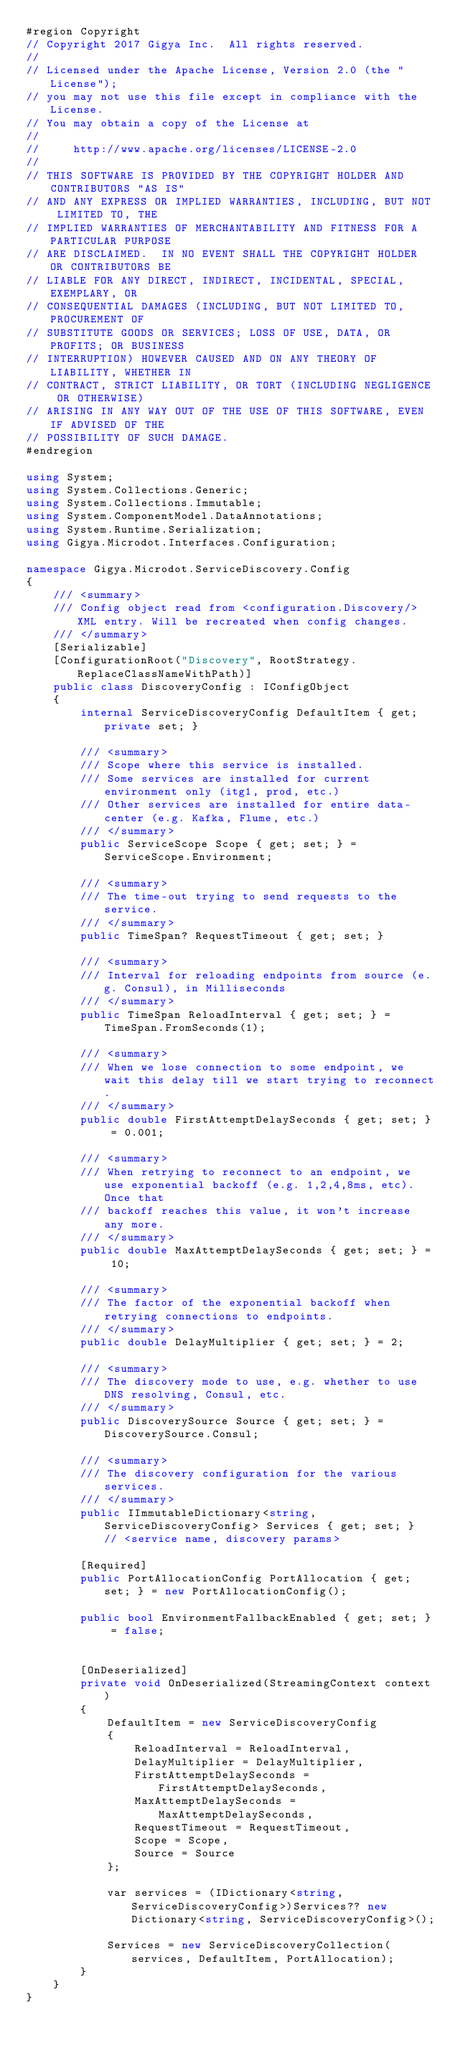Convert code to text. <code><loc_0><loc_0><loc_500><loc_500><_C#_>#region Copyright 
// Copyright 2017 Gigya Inc.  All rights reserved.
// 
// Licensed under the Apache License, Version 2.0 (the "License"); 
// you may not use this file except in compliance with the License.  
// You may obtain a copy of the License at
// 
//     http://www.apache.org/licenses/LICENSE-2.0
// 
// THIS SOFTWARE IS PROVIDED BY THE COPYRIGHT HOLDER AND CONTRIBUTORS "AS IS"
// AND ANY EXPRESS OR IMPLIED WARRANTIES, INCLUDING, BUT NOT LIMITED TO, THE
// IMPLIED WARRANTIES OF MERCHANTABILITY AND FITNESS FOR A PARTICULAR PURPOSE
// ARE DISCLAIMED.  IN NO EVENT SHALL THE COPYRIGHT HOLDER OR CONTRIBUTORS BE
// LIABLE FOR ANY DIRECT, INDIRECT, INCIDENTAL, SPECIAL, EXEMPLARY, OR
// CONSEQUENTIAL DAMAGES (INCLUDING, BUT NOT LIMITED TO, PROCUREMENT OF
// SUBSTITUTE GOODS OR SERVICES; LOSS OF USE, DATA, OR PROFITS; OR BUSINESS
// INTERRUPTION) HOWEVER CAUSED AND ON ANY THEORY OF LIABILITY, WHETHER IN
// CONTRACT, STRICT LIABILITY, OR TORT (INCLUDING NEGLIGENCE OR OTHERWISE)
// ARISING IN ANY WAY OUT OF THE USE OF THIS SOFTWARE, EVEN IF ADVISED OF THE
// POSSIBILITY OF SUCH DAMAGE.
#endregion

using System;
using System.Collections.Generic;
using System.Collections.Immutable;
using System.ComponentModel.DataAnnotations;
using System.Runtime.Serialization;
using Gigya.Microdot.Interfaces.Configuration;

namespace Gigya.Microdot.ServiceDiscovery.Config
{
    /// <summary>
    /// Config object read from <configuration.Discovery/> XML entry. Will be recreated when config changes.
    /// </summary>
    [Serializable]
    [ConfigurationRoot("Discovery", RootStrategy.ReplaceClassNameWithPath)]
    public class DiscoveryConfig : IConfigObject
    {
        internal ServiceDiscoveryConfig DefaultItem { get; private set; }

        /// <summary>
        /// Scope where this service is installed.
        /// Some services are installed for current environment only (itg1, prod, etc.)
        /// Other services are installed for entire data-center (e.g. Kafka, Flume, etc.)
        /// </summary>
        public ServiceScope Scope { get; set; } = ServiceScope.Environment;

        /// <summary>
        /// The time-out trying to send requests to the service.
        /// </summary>
        public TimeSpan? RequestTimeout { get; set; }

        /// <summary>
        /// Interval for reloading endpoints from source (e.g. Consul), in Milliseconds
        /// </summary>
        public TimeSpan ReloadInterval { get; set; } = TimeSpan.FromSeconds(1);

        /// <summary>
        /// When we lose connection to some endpoint, we wait this delay till we start trying to reconnect.
        /// </summary>
        public double FirstAttemptDelaySeconds { get; set; } = 0.001;

        /// <summary>
        /// When retrying to reconnect to an endpoint, we use exponential backoff (e.g. 1,2,4,8ms, etc). Once that
        /// backoff reaches this value, it won't increase any more.
        /// </summary>
        public double MaxAttemptDelaySeconds { get; set; } = 10;

        /// <summary>
        /// The factor of the exponential backoff when retrying connections to endpoints.
        /// </summary>
        public double DelayMultiplier { get; set; } = 2;

        /// <summary>
        /// The discovery mode to use, e.g. whether to use DNS resolving, Consul, etc.
        /// </summary>
        public DiscoverySource Source { get; set; } = DiscoverySource.Consul;

        /// <summary>
        /// The discovery configuration for the various services.
        /// </summary>
        public IImmutableDictionary<string, ServiceDiscoveryConfig> Services { get; set; }  // <service name, discovery params>

        [Required]
        public PortAllocationConfig PortAllocation { get; set; } = new PortAllocationConfig();

        public bool EnvironmentFallbackEnabled { get; set; } = false;


        [OnDeserialized]
        private void OnDeserialized(StreamingContext context)
        {
            DefaultItem = new ServiceDiscoveryConfig
            {
                ReloadInterval = ReloadInterval,
                DelayMultiplier = DelayMultiplier,
                FirstAttemptDelaySeconds = FirstAttemptDelaySeconds,
                MaxAttemptDelaySeconds = MaxAttemptDelaySeconds,
                RequestTimeout = RequestTimeout,
                Scope = Scope,
                Source = Source
            };

            var services = (IDictionary<string, ServiceDiscoveryConfig>)Services?? new Dictionary<string, ServiceDiscoveryConfig>();
            
            Services = new ServiceDiscoveryCollection(services, DefaultItem, PortAllocation);
        }
    }
}</code> 